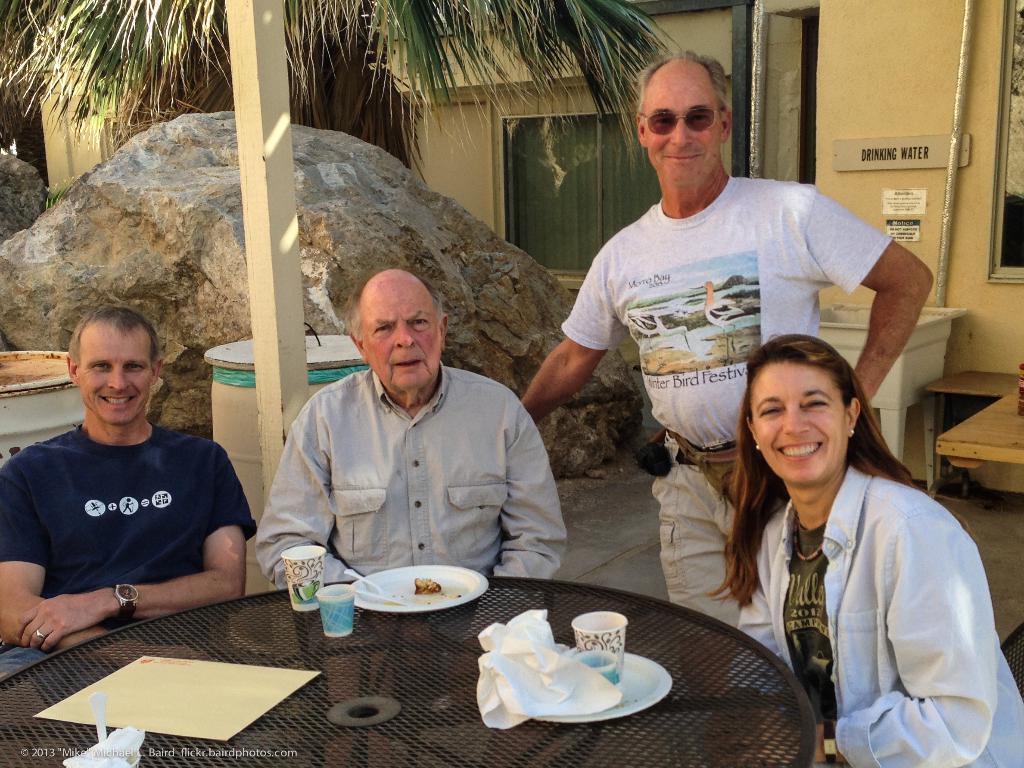Describe this image in one or two sentences. In this picture we can see three persons are sitting on the chairs. This is table. On the table there are plates, glasses, and a paper. Here we can see a man who is standing on the floor. He has goggles. On the background there is a wall and this is window. Here we can see a tree. And this is stone. 